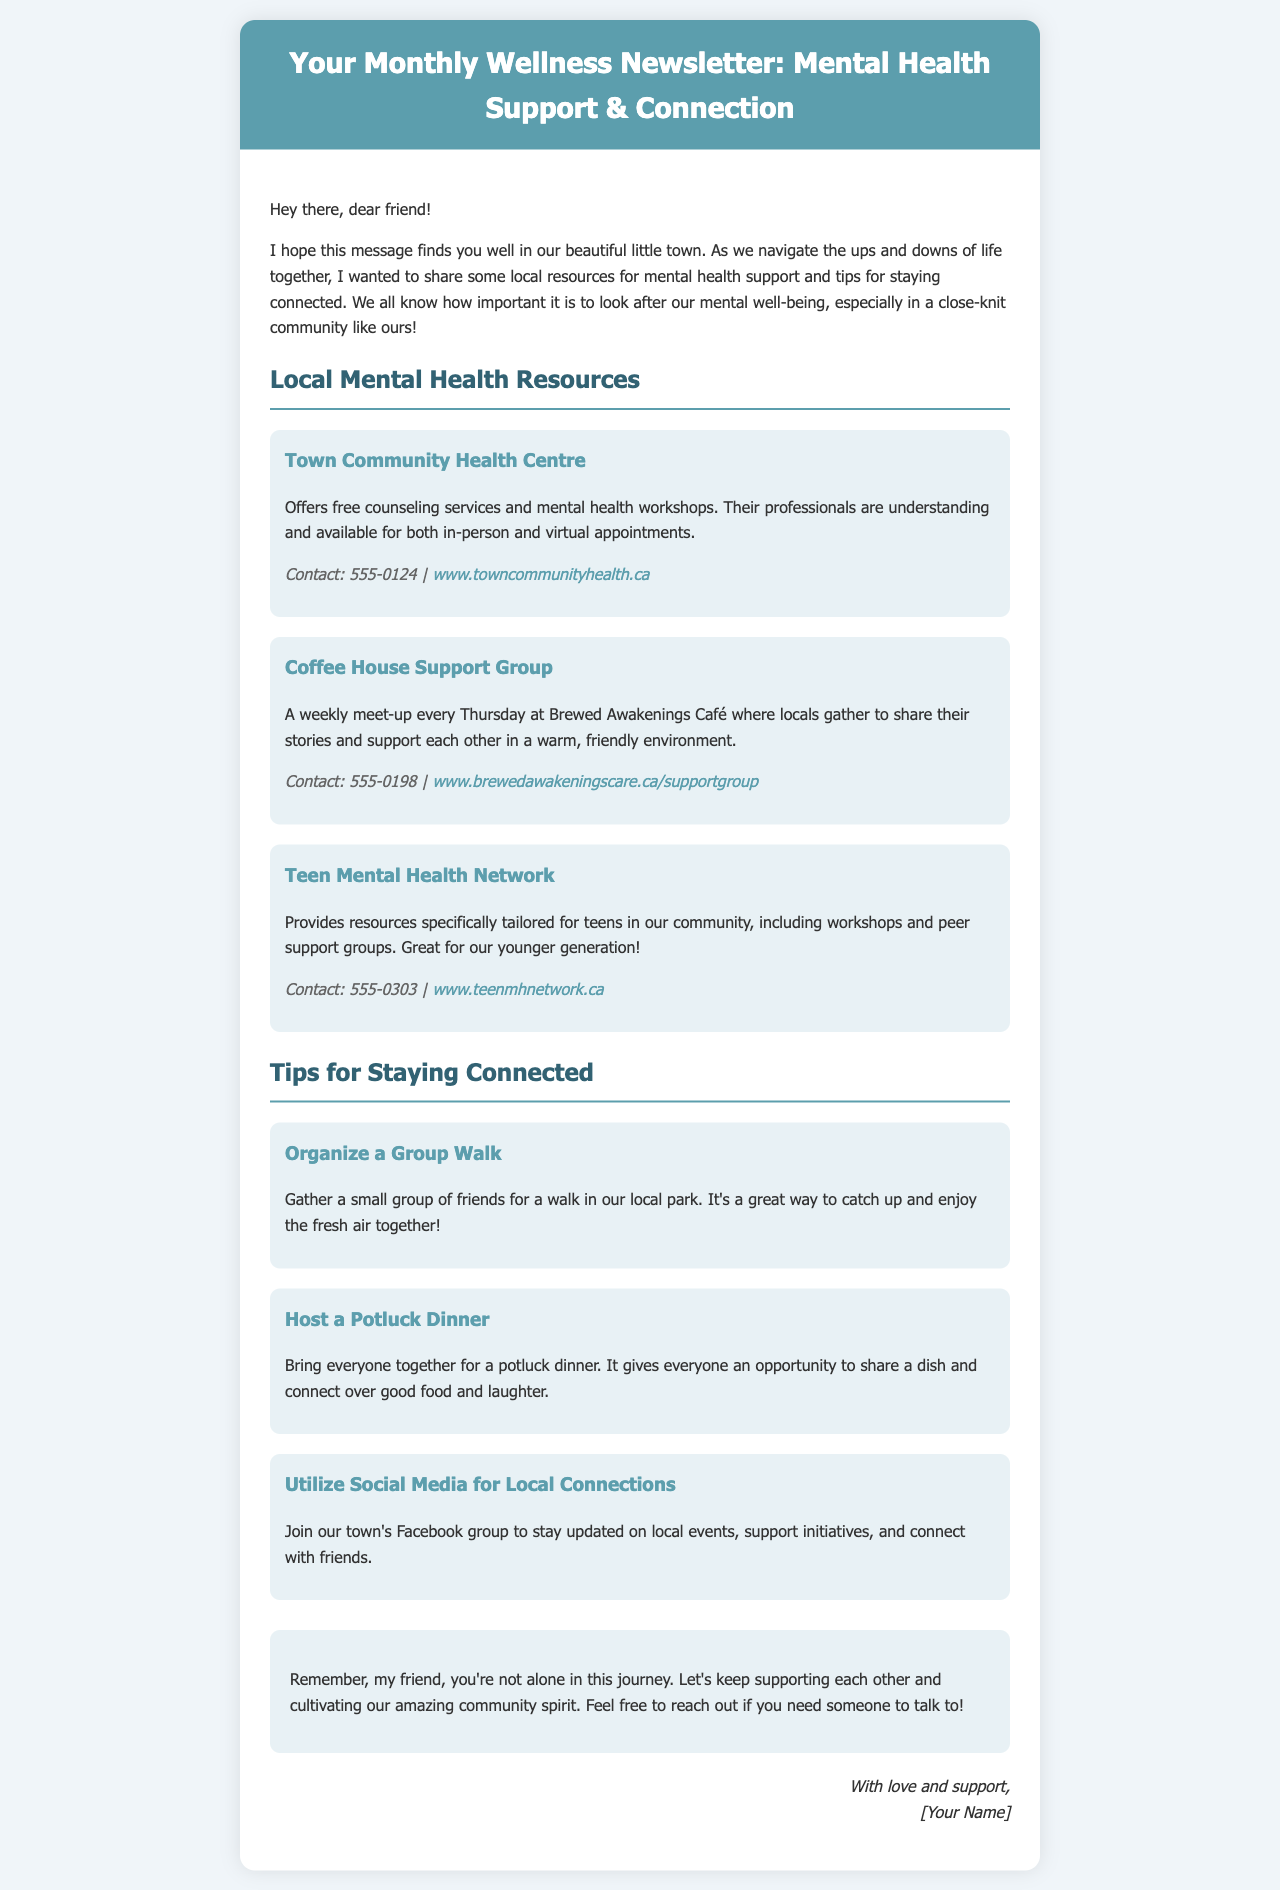what is the title of the newsletter? The title is prominently displayed in the header of the newsletter.
Answer: Your Monthly Wellness Newsletter: Mental Health Support & Connection how often is the newsletter sent? The frequency of the newsletter can be inferred from the title of the document.
Answer: Monthly what is the contact number for the Town Community Health Centre? The contact number is specifically mentioned under the resource section for the Town Community Health Centre.
Answer: 555-0124 what day of the week does the Coffee House Support Group meet? The meeting day is stated within the description of the Coffee House Support Group resource.
Answer: Thursday what is one way to stay connected according to the tips? The tips section includes various suggestions to stay connected, one of them is mentioned clearly.
Answer: Organize a Group Walk how many tips for staying connected are provided in the newsletter? The document lists the number of tips provided under the section for staying connected.
Answer: Three which resource is aimed specifically at teenagers? The document specifies the resource that targets teenagers, as mentioned in the title of the resource.
Answer: Teen Mental Health Network what type of event is suggested for a potluck dinner? The nature of the potluck dinner event is described in the tips section related to hosting gatherings.
Answer: Bring everyone together how does the author sign off in the email? The sign-off is found at the end of the newsletter, indicating the author's closing statement.
Answer: With love and support, [Your Name] 